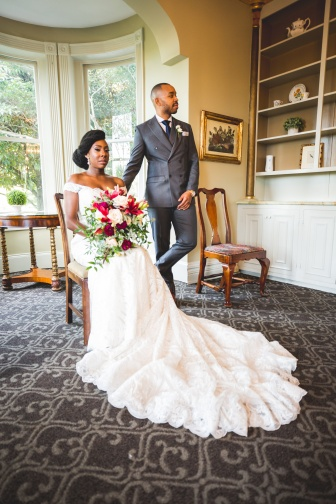What will the bride and groom remember most about this moment? The bride and groom will likely remember the deep sense of love and connection they felt in this intimate moment. The serene atmosphere of the room, the natural light casting a warm glow, and the quiet joy shared between them will become a treasured memory, symbolizing the beginning of their new life together. Describe in detail the background elements in the image and their potential significance. The background of the image includes several notable elements, each adding to the overall ambiance and storytelling. To the left, a large window allows natural light to bathe the room, creating a warm and inviting atmosphere. The greenery visible through the window suggests a connection to nature, adding a touch of serenity to the scene.

A wooden table and chairs occupy space behind the couple, implying a setting where meaningful conversations and shared meals might occur, contributing to the domesticity and warmth of their future home. The elegant bookcase along the wall is partly filled with decorative items and books. Its presence signifies a place of knowledge, growth, and shared experiences, perhaps hinting at the couple's mutual interests or future intellectual endeavors.

Altogether, these background elements enhance the narrative, suggesting a life filled with love, learning, and cherished moments in an elegant and thoughtfully curated environment. Craft a whimsical short story about the bookcase in the background. In a quaint, sunlit room, there stood an enchanted bookcase that held dreams and stories beyond imagination. Every book was alive, whispering secrets and tales of magical lands. The couple who owned it, unaware of its magic, often found themselves lost in books that seemed to speak to their souls. One evening, a dusty old tome glowed with an ethereal light, beckoning them to turn its pages. As they did, they were transported to a fantastical realm filled with talking animals, enchanted forests, and adventures that tested their bond. Together, they overcame challenges and discovered the true magic of their love.

Upon returning, they found that the experiences in the story had deepened their connection in the real world. The bookcase remained their portal to countless adventures, always reminding them that love and imagination could conquer any obstacle. 